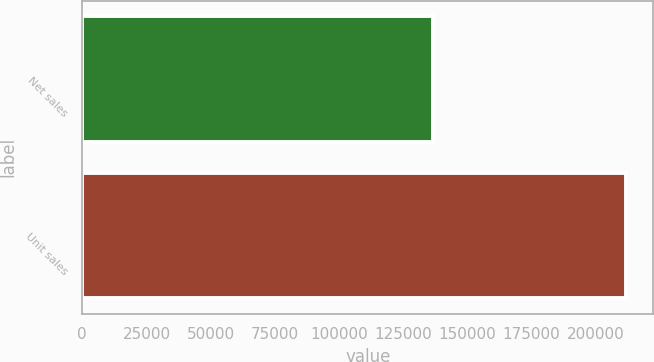Convert chart. <chart><loc_0><loc_0><loc_500><loc_500><bar_chart><fcel>Net sales<fcel>Unit sales<nl><fcel>136700<fcel>211884<nl></chart> 